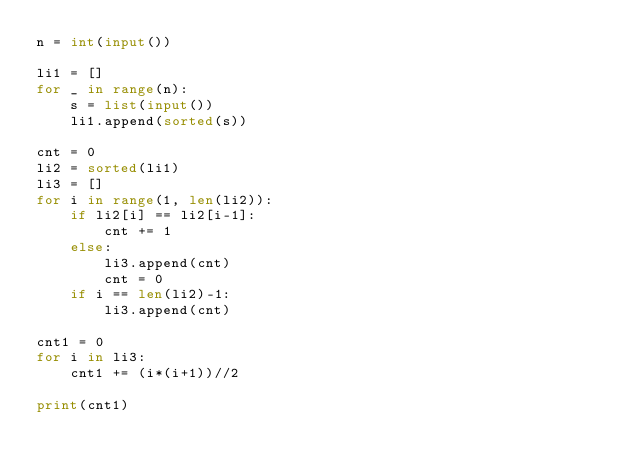Convert code to text. <code><loc_0><loc_0><loc_500><loc_500><_Python_>n = int(input())

li1 = []
for _ in range(n):
    s = list(input())
    li1.append(sorted(s))

cnt = 0
li2 = sorted(li1)
li3 = []
for i in range(1, len(li2)):
    if li2[i] == li2[i-1]:
        cnt += 1
    else:
        li3.append(cnt)
        cnt = 0
    if i == len(li2)-1:
        li3.append(cnt)

cnt1 = 0
for i in li3:
    cnt1 += (i*(i+1))//2
    
print(cnt1)</code> 